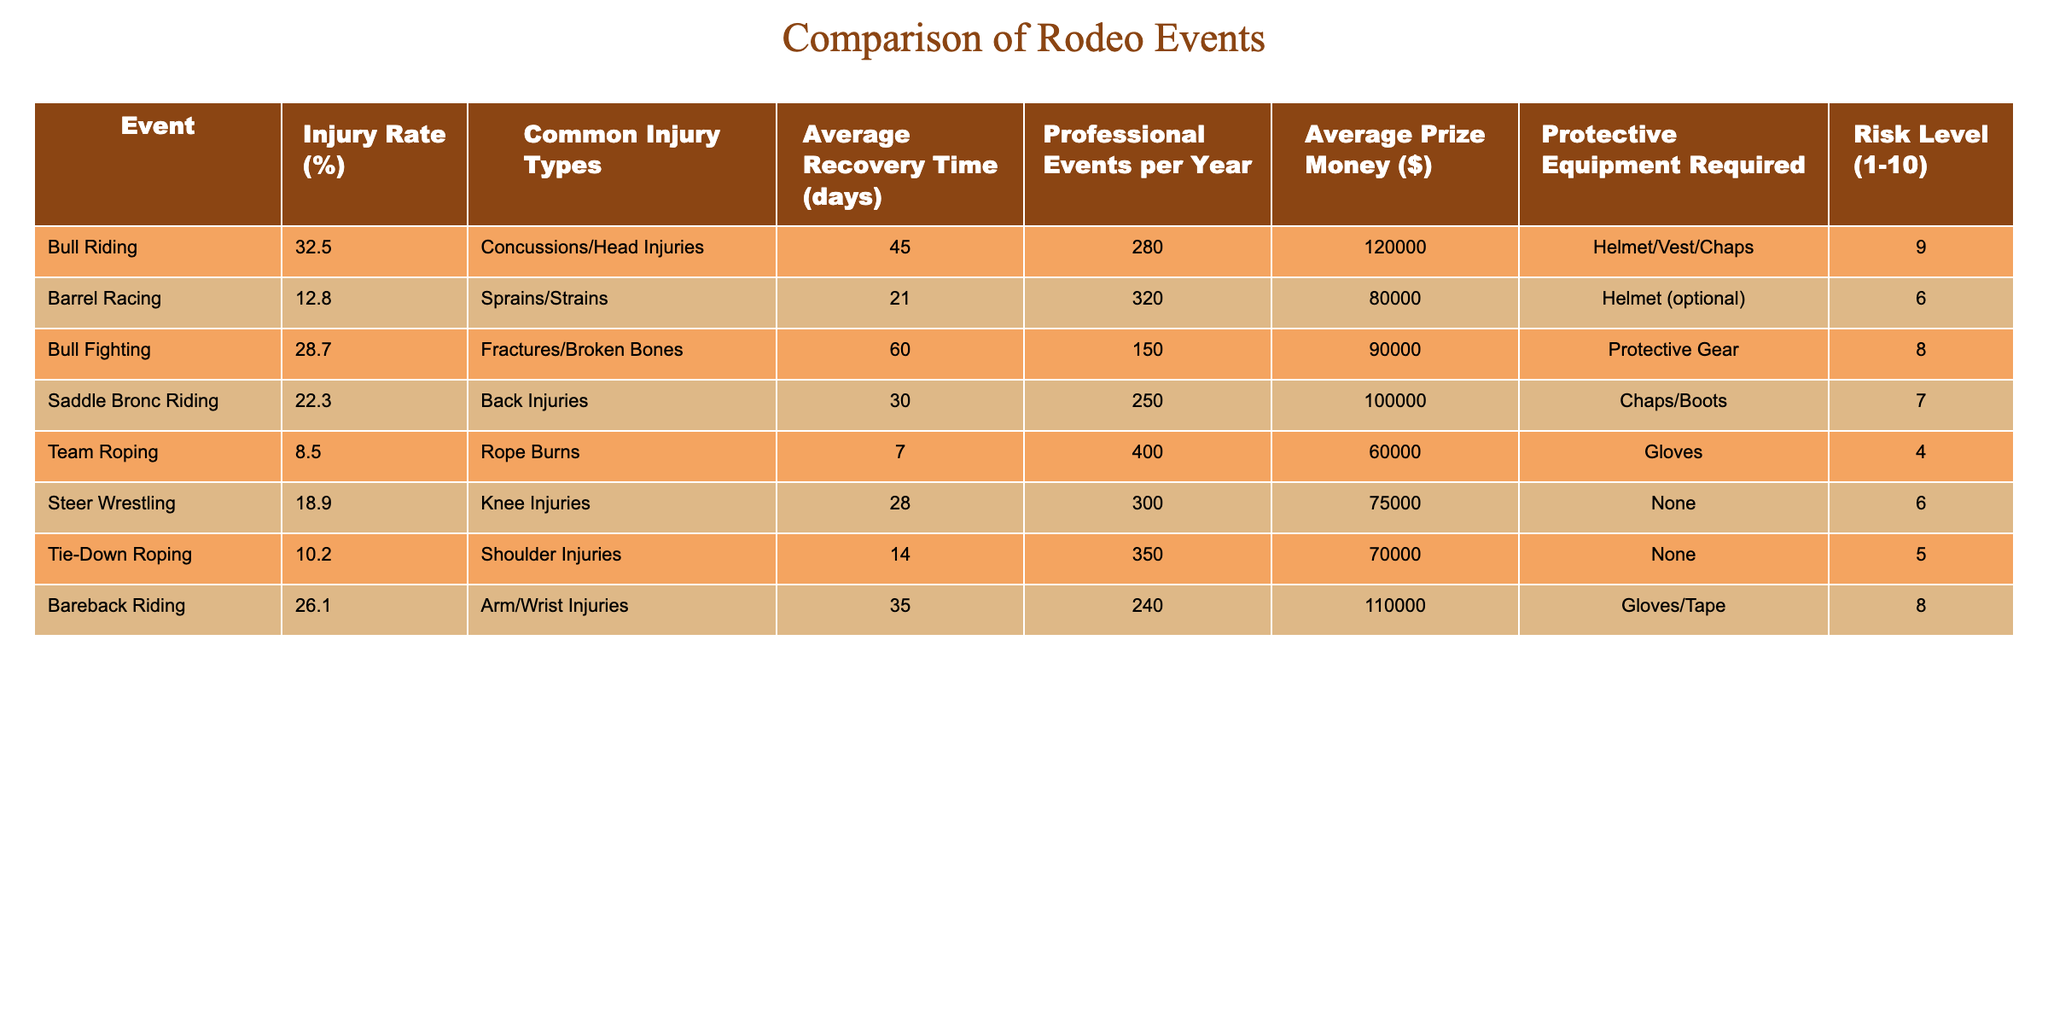What is the injury rate for bull riding? The table directly shows the injury rate for bull riding as 32.5%.
Answer: 32.5% How many common injury types are there in barrel racing? The table lists one common injury type for barrel racing, which is sprains and strains.
Answer: 1 What is the average recovery time for bull fighting? The table states that the average recovery time for bull fighting is 60 days.
Answer: 60 days What is the injury rate difference between bull riding and barrel racing? The injury rate for bull riding is 32.5%, and for barrel racing, it is 12.8%. The difference is calculated as 32.5% - 12.8% = 19.7%.
Answer: 19.7% Which event has the highest average prize money? The table shows that bull riding has the highest average prize money at $120,000.
Answer: Bull riding Is the protective equipment required for barrel racing more extensive than for bull riding? The table indicates that bull riding requires a helmet, vest, and chaps, while barrel racing only requires a helmet (optional). So, bull riding has more extensive required protective equipment.
Answer: No What is the average injury rate across all the listed events? To find the average, we add up all the injury rates: (32.5 + 12.8 + 28.7 + 22.3 + 8.5 + 18.9 + 10.2 + 26.1) and divide by 8. The total is  28.75, and the average is 28.75 / 8 = 18.44%.
Answer: 18.44% Which event has the lowest risk level? The table shows that team roping has the lowest risk level at 4.
Answer: Team roping Does bull riding have a higher average recovery time than barrel racing? The average recovery time for bull riding is 45 days, and for barrel racing, it is 21 days. Since 45 is greater than 21, bull riding does have a higher average recovery time.
Answer: Yes How many more professional events are held per year for barrel racing than for bull riding? The table lists 320 professional events for barrel racing and 280 for bull riding. The difference is 320 - 280 = 40 more events for barrel racing.
Answer: 40 What types of injuries are most common in bull riding? The table indicates that concussions and head injuries are the common injury types for bull riding.
Answer: Concussions/Head Injuries 